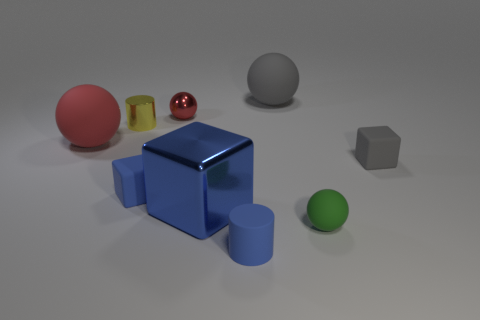Subtract all big red matte balls. How many balls are left? 3 Subtract all green balls. How many balls are left? 3 Subtract all blocks. How many objects are left? 6 Subtract 3 cubes. How many cubes are left? 0 Subtract all red cylinders. Subtract all purple spheres. How many cylinders are left? 2 Subtract all purple cylinders. How many yellow blocks are left? 0 Subtract all large spheres. Subtract all small yellow metal things. How many objects are left? 6 Add 8 tiny shiny balls. How many tiny shiny balls are left? 9 Add 2 tiny yellow blocks. How many tiny yellow blocks exist? 2 Subtract 0 gray cylinders. How many objects are left? 9 